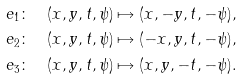<formula> <loc_0><loc_0><loc_500><loc_500>e _ { 1 } \colon & \quad ( x , y , t , \psi ) \mapsto ( x , - y , t , - \psi ) , \\ e _ { 2 } \colon & \quad ( x , y , t , \psi ) \mapsto ( - x , y , t , - \psi ) , \\ e _ { 3 } \colon & \quad ( x , y , t , \psi ) \mapsto ( x , y , - t , - \psi ) .</formula> 